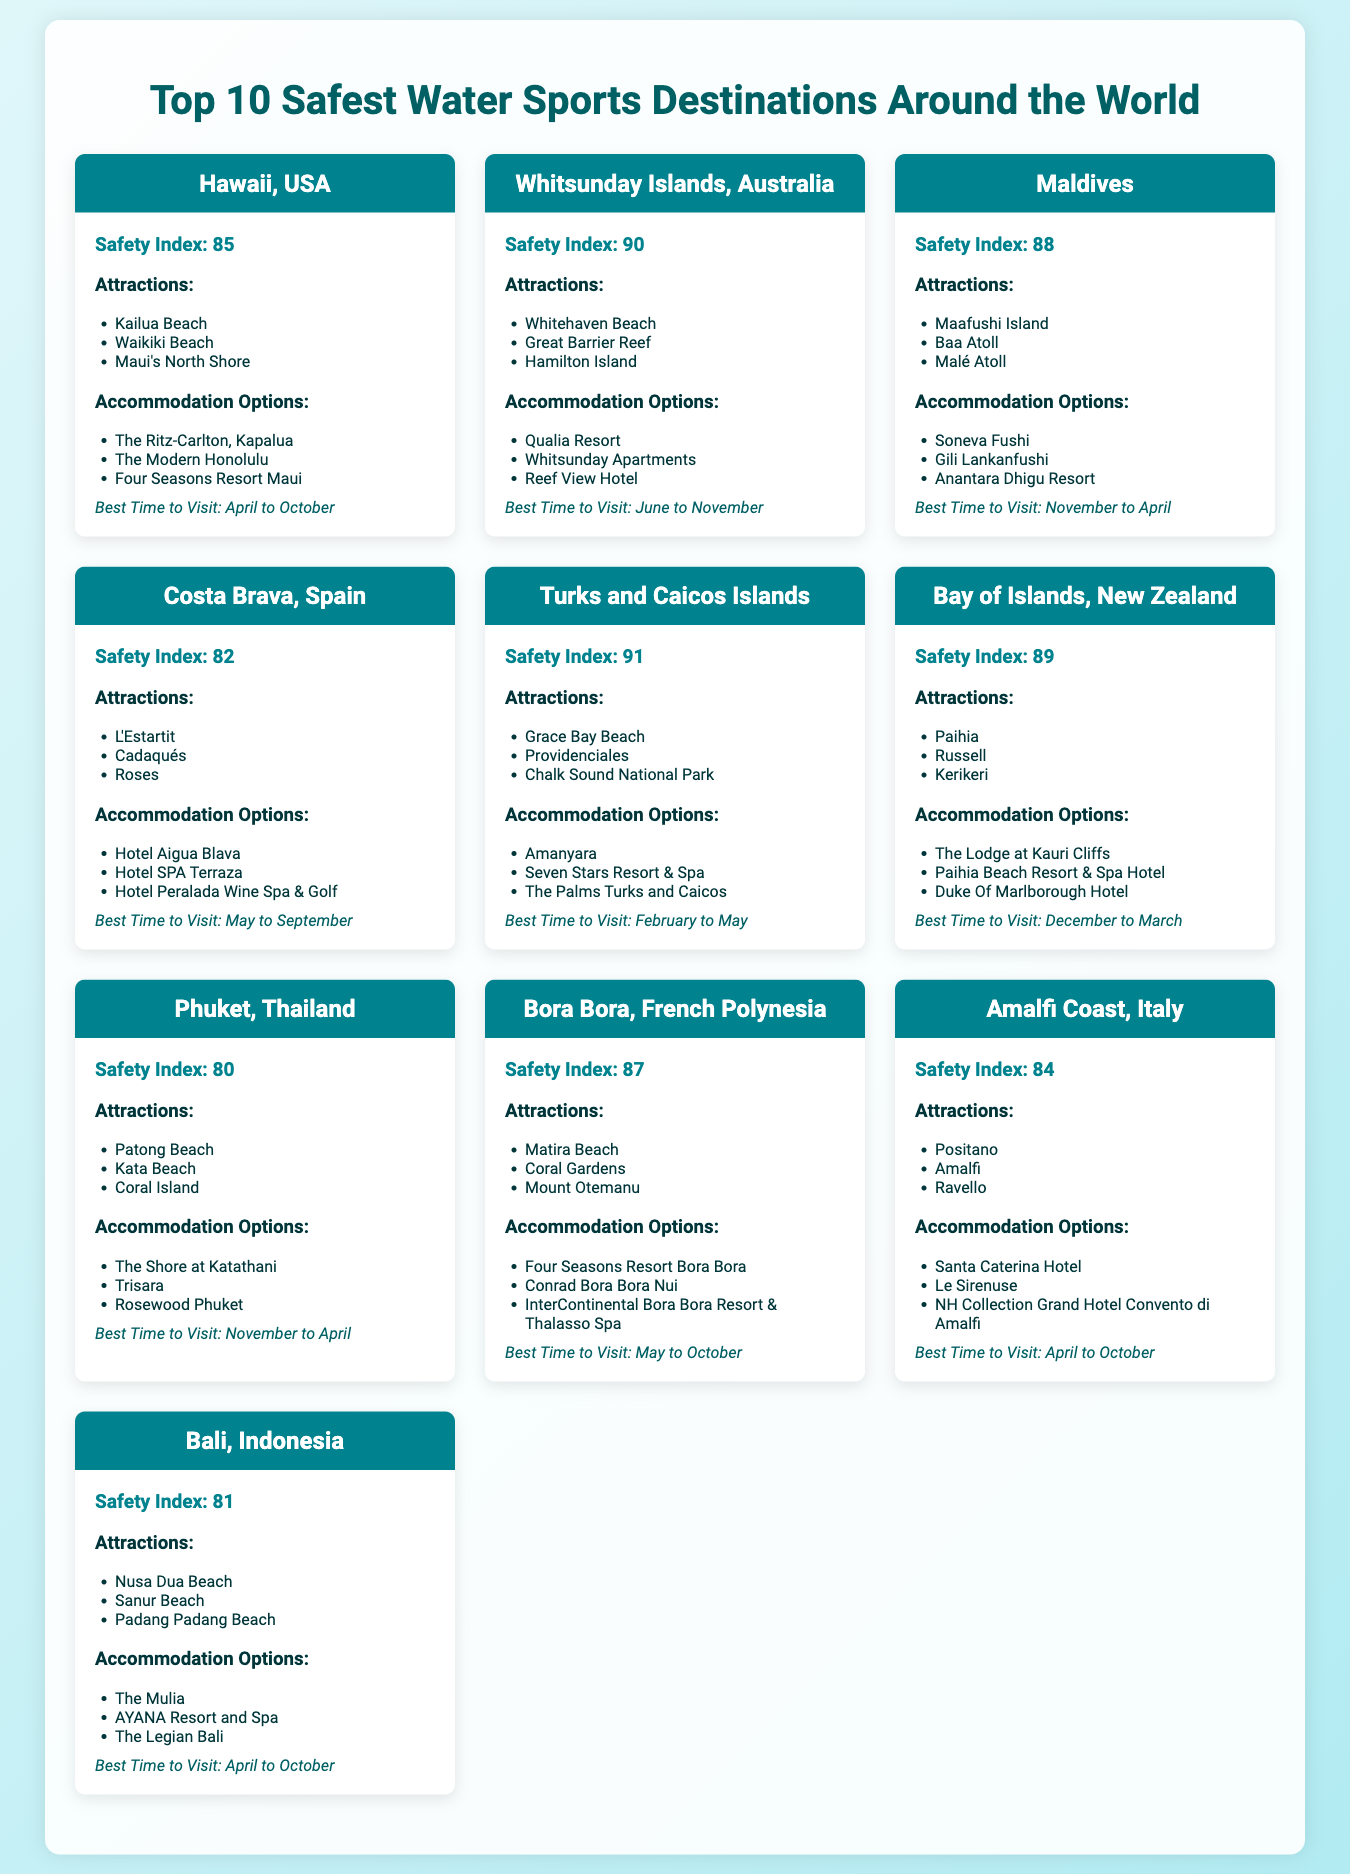What is the safety index of Hawaii? The safety index of Hawaii is mentioned directly in the document as 85.
Answer: 85 Which destination has the highest safety index? The destination with the highest safety index in the document is Whitsunday Islands, Australia, with a rating of 90.
Answer: Whitsunday Islands, Australia What are the best months to visit Maldives? The document states that the best time to visit Maldives is from November to April.
Answer: November to April List one accommodation option in Phuket. The document lists multiple accommodation options for Phuket; one option is The Shore at Katathani.
Answer: The Shore at Katathani What is a popular attraction in Costa Brava? The document mentions L'Estartit as one of the attractions in Costa Brava.
Answer: L'Estartit Identify two attractions in the Turks and Caicos Islands. The document lists Grace Bay Beach and Providenciales as attractions in the Turks and Caicos Islands.
Answer: Grace Bay Beach, Providenciales Which destination has the lowest safety index? The lowest safety index in the list belongs to Phuket, Thailand, with a score of 80.
Answer: Phuket, Thailand When is the best time to visit Bora Bora? According to the document, the best time to visit Bora Bora is from May to October.
Answer: May to October What type of document is this? The document provides a visual representation of safety ratings and travel information for water sports destinations.
Answer: Informational infographic 